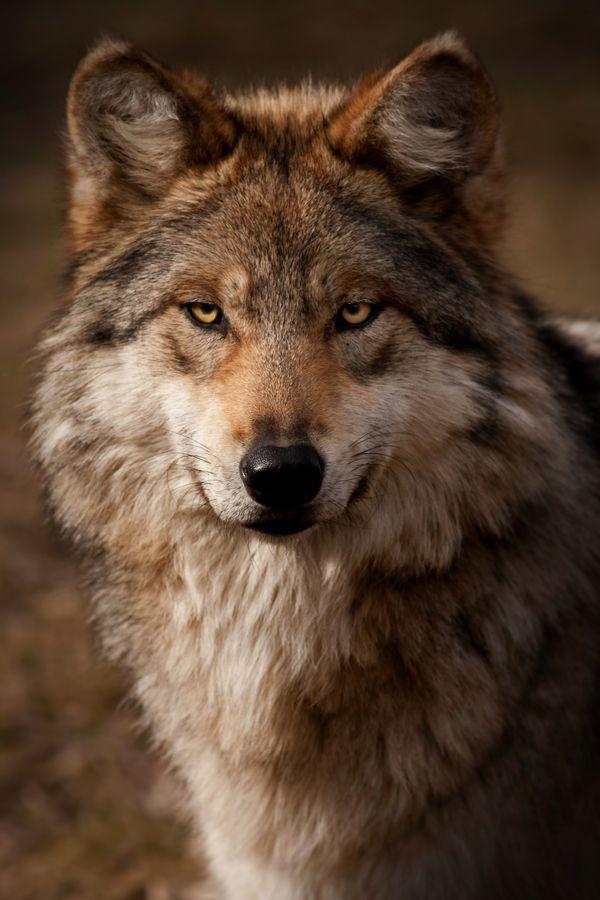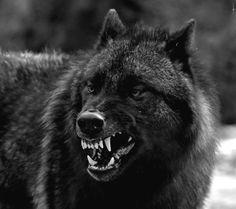The first image is the image on the left, the second image is the image on the right. Evaluate the accuracy of this statement regarding the images: "At least one image shows a wolf baring its fangs.". Is it true? Answer yes or no. Yes. The first image is the image on the left, the second image is the image on the right. Analyze the images presented: Is the assertion "The dog on the right is baring its teeth." valid? Answer yes or no. Yes. 